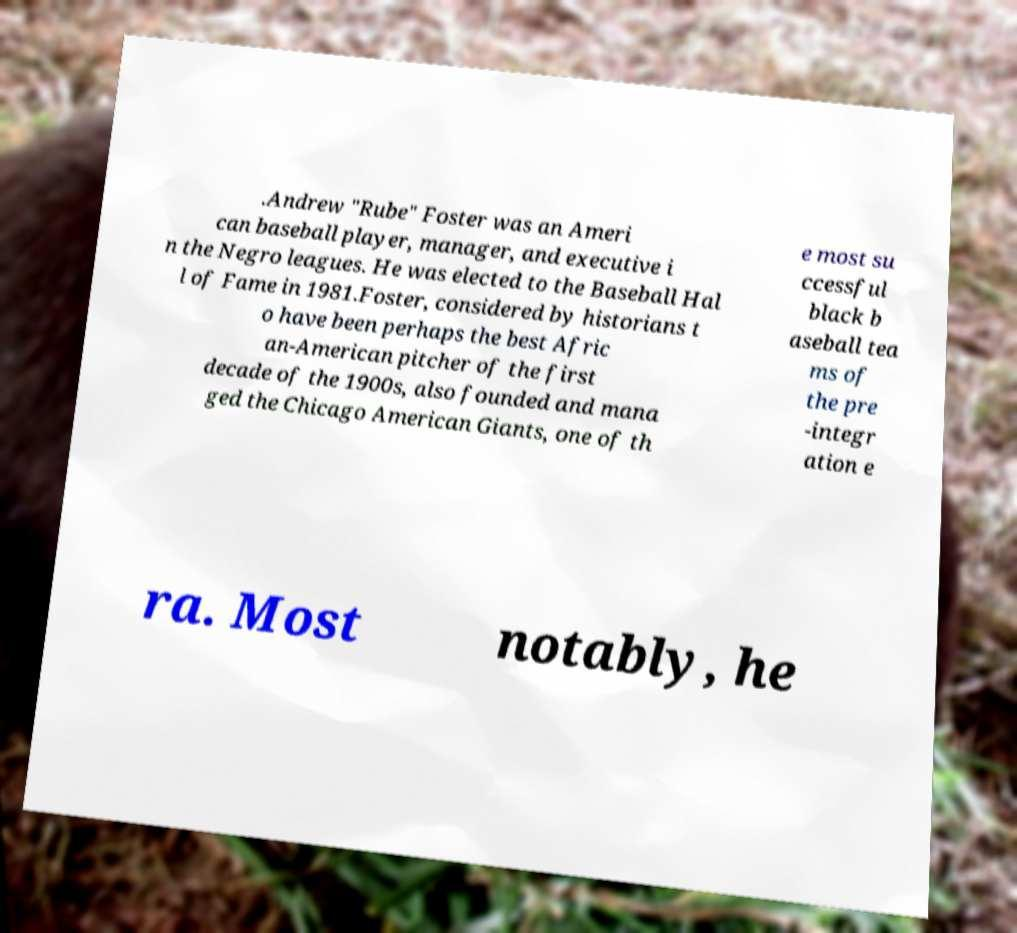Can you accurately transcribe the text from the provided image for me? .Andrew "Rube" Foster was an Ameri can baseball player, manager, and executive i n the Negro leagues. He was elected to the Baseball Hal l of Fame in 1981.Foster, considered by historians t o have been perhaps the best Afric an-American pitcher of the first decade of the 1900s, also founded and mana ged the Chicago American Giants, one of th e most su ccessful black b aseball tea ms of the pre -integr ation e ra. Most notably, he 